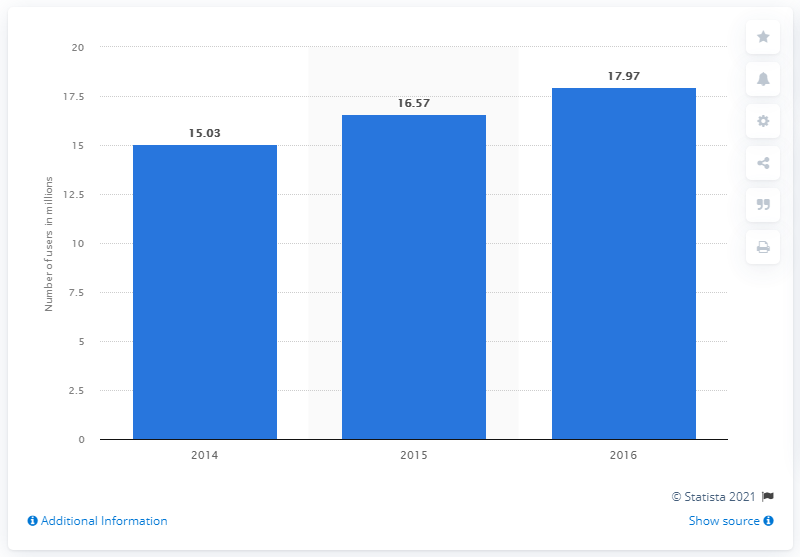Indicate a few pertinent items in this graphic. In 2015, there were approximately 16.57 million Twitter users in Brazil. 